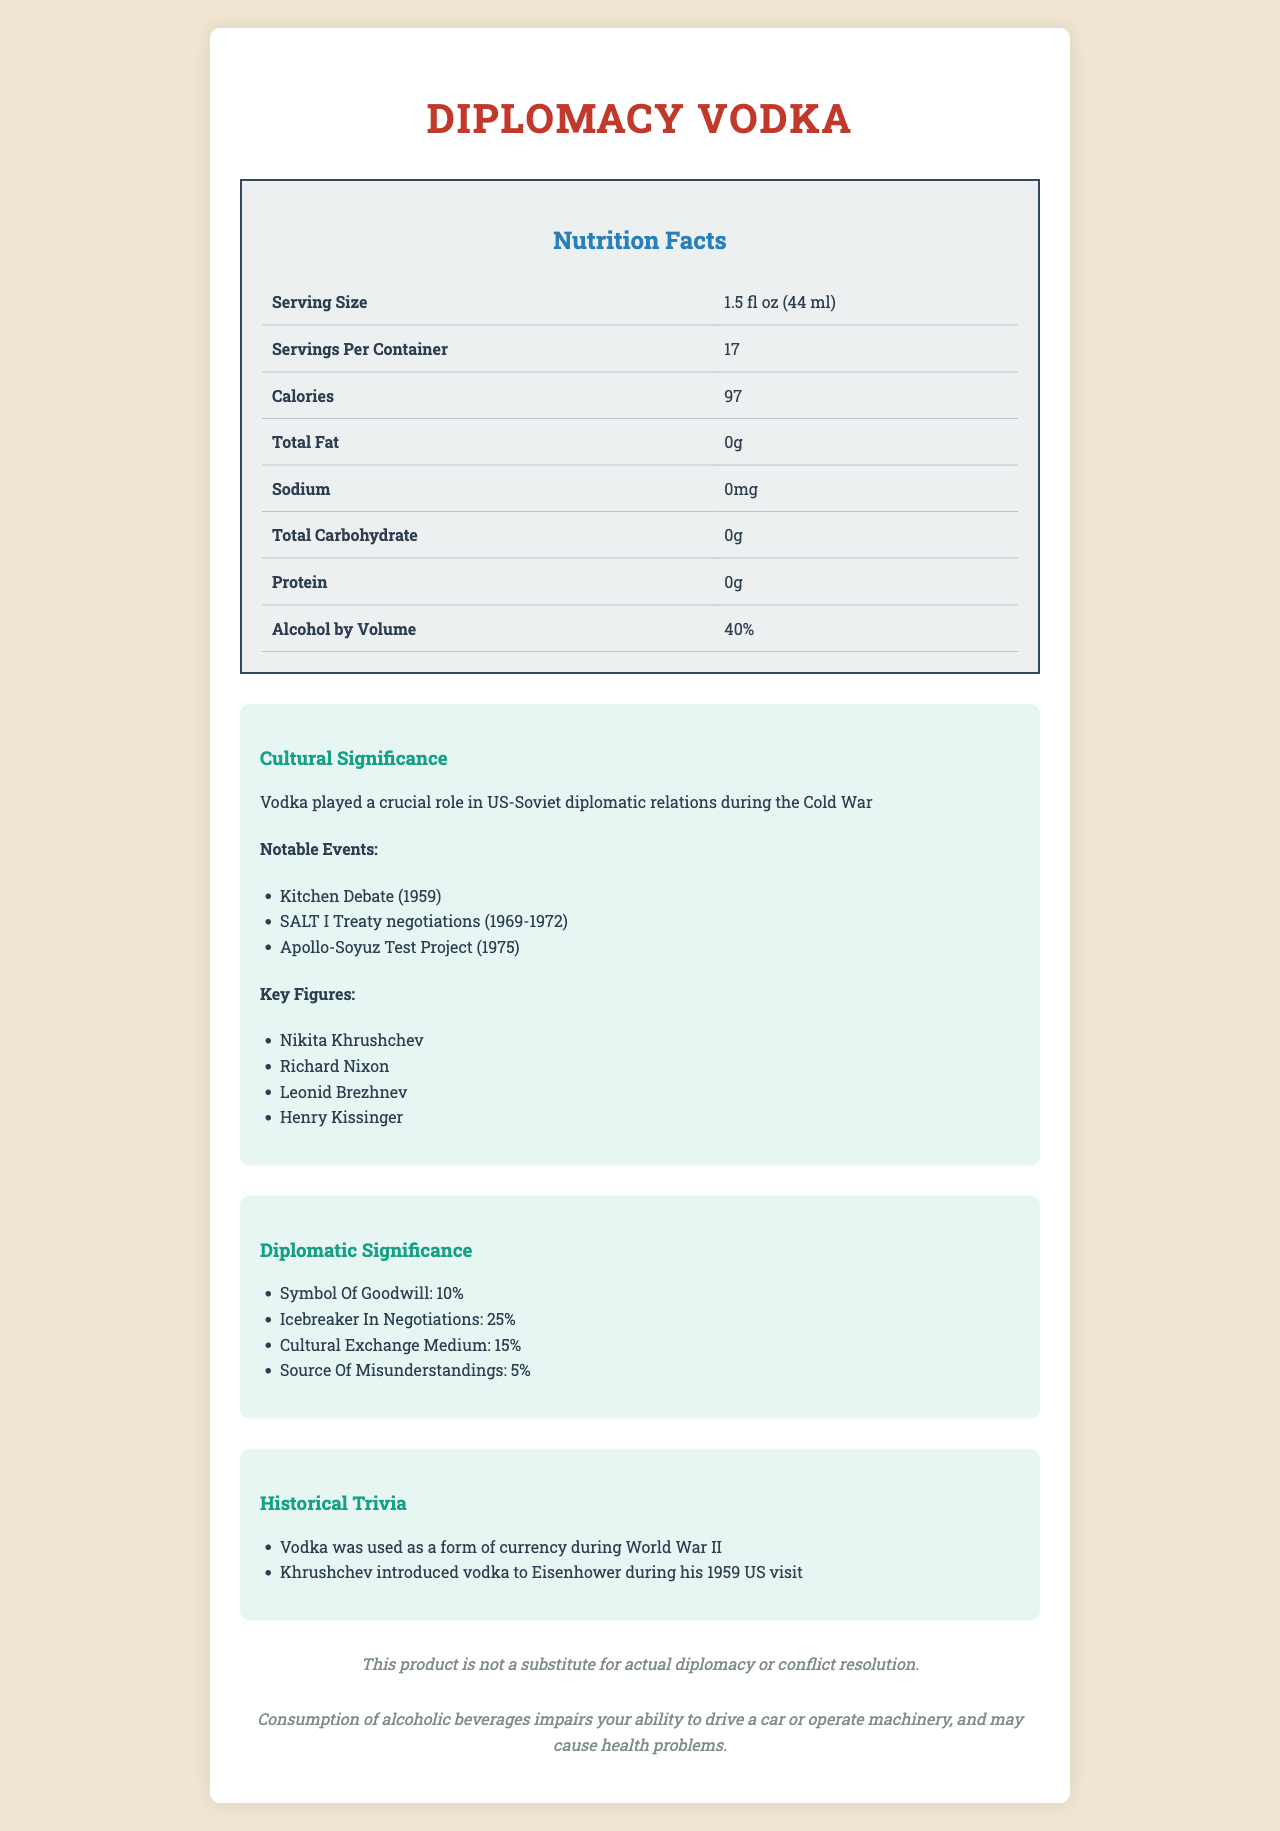What is the serving size of Diplomacy Vodka? The serving size is clearly mentioned at the top of the Nutrition Facts Label.
Answer: 1.5 fl oz (44 ml) What is the alcohol content of Diplomacy Vodka by volume? The alcohol by volume is listed in the Nutrition Facts table.
Answer: 40% Which notable event involved both United States President Richard Nixon and Soviet Premier Nikita Khrushchev? A. SALT I Treaty negotiations B. Apollo-Soyuz Test Project C. Kitchen Debate The Kitchen Debate (1959) is a notable event that involved both Richard Nixon and Nikita Khrushchev.
Answer: C. Kitchen Debate What method is used for the distillation process of Diplomacy Vodka? The distillation process mentions the use of a continuous column still.
Answer: Continuous column still What historical role did vodka play according to the trivia section? This information is provided in the Historical Trivia section of the document.
Answer: Vodka was used as a form of currency during World War II Which figure introduced vodka to Eisenhower during his 1959 US visit? The Historical Trivia section states that Khrushchev introduced vodka to Eisenhower during his 1959 US visit.
Answer: Khrushchev How many servings are contained within one bottle of Diplomacy Vodka? This information is provided in the Nutrition Facts table under "Servings Per Container."
Answer: 17 What is the sodium content per serving of Diplomacy Vodka? Sodium content is listed in the Nutrition Facts table as 0mg.
Answer: 0mg What are the primary ingredients of Diplomacy Vodka? The ingredients are listed under the ingredients section.
Answer: Water and Wheat grain spirit In which region of the Soviet Union is Diplomacy Vodka produced? The origin section lists Moscow Oblast as the region of production.
Answer: Moscow Oblast What year was Pepsi Cola introduced in the USSR according to the cultural exchange section? A. 1962 B. 1972 C. 1982 The document mentions Pepsi Cola being introduced in the USSR in 1972 as part of cultural exchanges.
Answer: B. 1972 Did the document mention Henry Kissinger as one of the key figures in US-Soviet diplomatic relations? The Cultural Significance section lists Henry Kissinger as one of the key figures.
Answer: Yes Do the nutritional facts indicate Diplomacy Vodka contains any protein? The Nutrition Facts table shows 0g of protein.
Answer: No Give a brief overview of the cultural and historical significance of Diplomacy Vodka. The document, through various sections—such as Historical Context, Notable Events, Key Figures, and Diplomatic Toasts—highlights the crucial role vodka played in diplomatic interactions between the US and the USSR. It underscored vodka's contribution to easing tensions and fostering goodwill.
Answer: Diplomacy Vodka, a product of the Soviet Union, carries substantial cultural and historical significance as a symbol of US-Soviet diplomatic relations. Prominent events like the Kitchen Debate, SALT I negotiations, and the Apollo-Soyuz Test Project are connected with this beverage. Important figures, including Khrushchev, Nixon, Brezhnev, and Kissinger, often used vodka to facilitate diplomatic toasts and ease discussions. Vodka's informal role in diplomacy helped reduce tensions and promote cultural exchange during the Cold War era. What was the exact amount of vodka Khrushchev introduced to Eisenhower? The document only states that Khrushchev introduced vodka to Eisenhower; it does not specify the amount.
Answer: Not enough information What cautionary advice is given regarding the consumption of Diplomacy Vodka? This cautionary note is provided at the end of the document in the disclaimer section.
Answer: Consumption of alcoholic beverages impairs your ability to drive a car or operate machinery, and may cause health problems. 